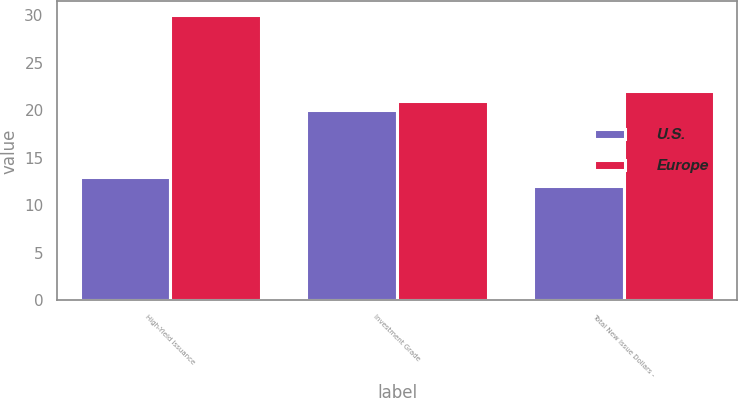<chart> <loc_0><loc_0><loc_500><loc_500><stacked_bar_chart><ecel><fcel>High-Yield Issuance<fcel>Investment Grade<fcel>Total New Issue Dollars -<nl><fcel>U.S.<fcel>13<fcel>20<fcel>12<nl><fcel>Europe<fcel>30<fcel>21<fcel>22<nl></chart> 